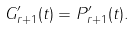Convert formula to latex. <formula><loc_0><loc_0><loc_500><loc_500>G _ { r + 1 } ^ { \prime } ( t ) = P _ { r + 1 } ^ { \prime } ( t ) .</formula> 